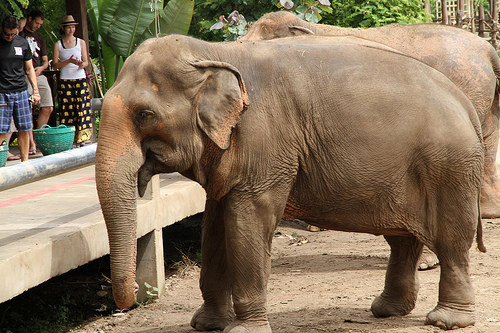What's the girl wearing? The girl is wearing a skirt. 